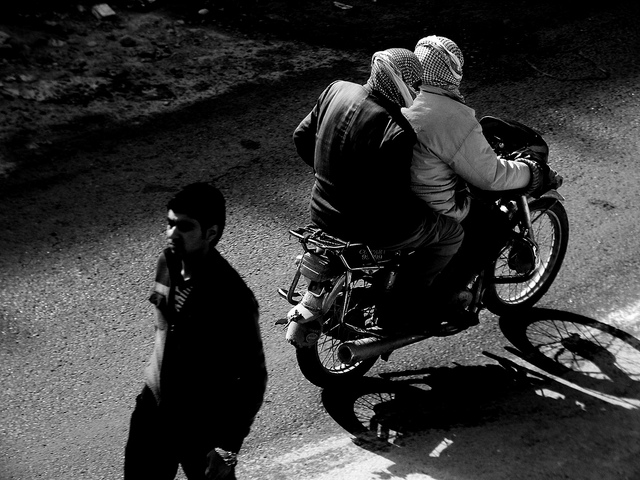What kind of attire are the individuals on the motorcycle wearing? Both individuals on the motorcycle are wearing layers that cover most of their bodies. The rider in front has a patterned garment that could be a keffiyeh around their head, while the second rider appears to be wearing a hooded piece of clothing, likely for protection or comfort. 